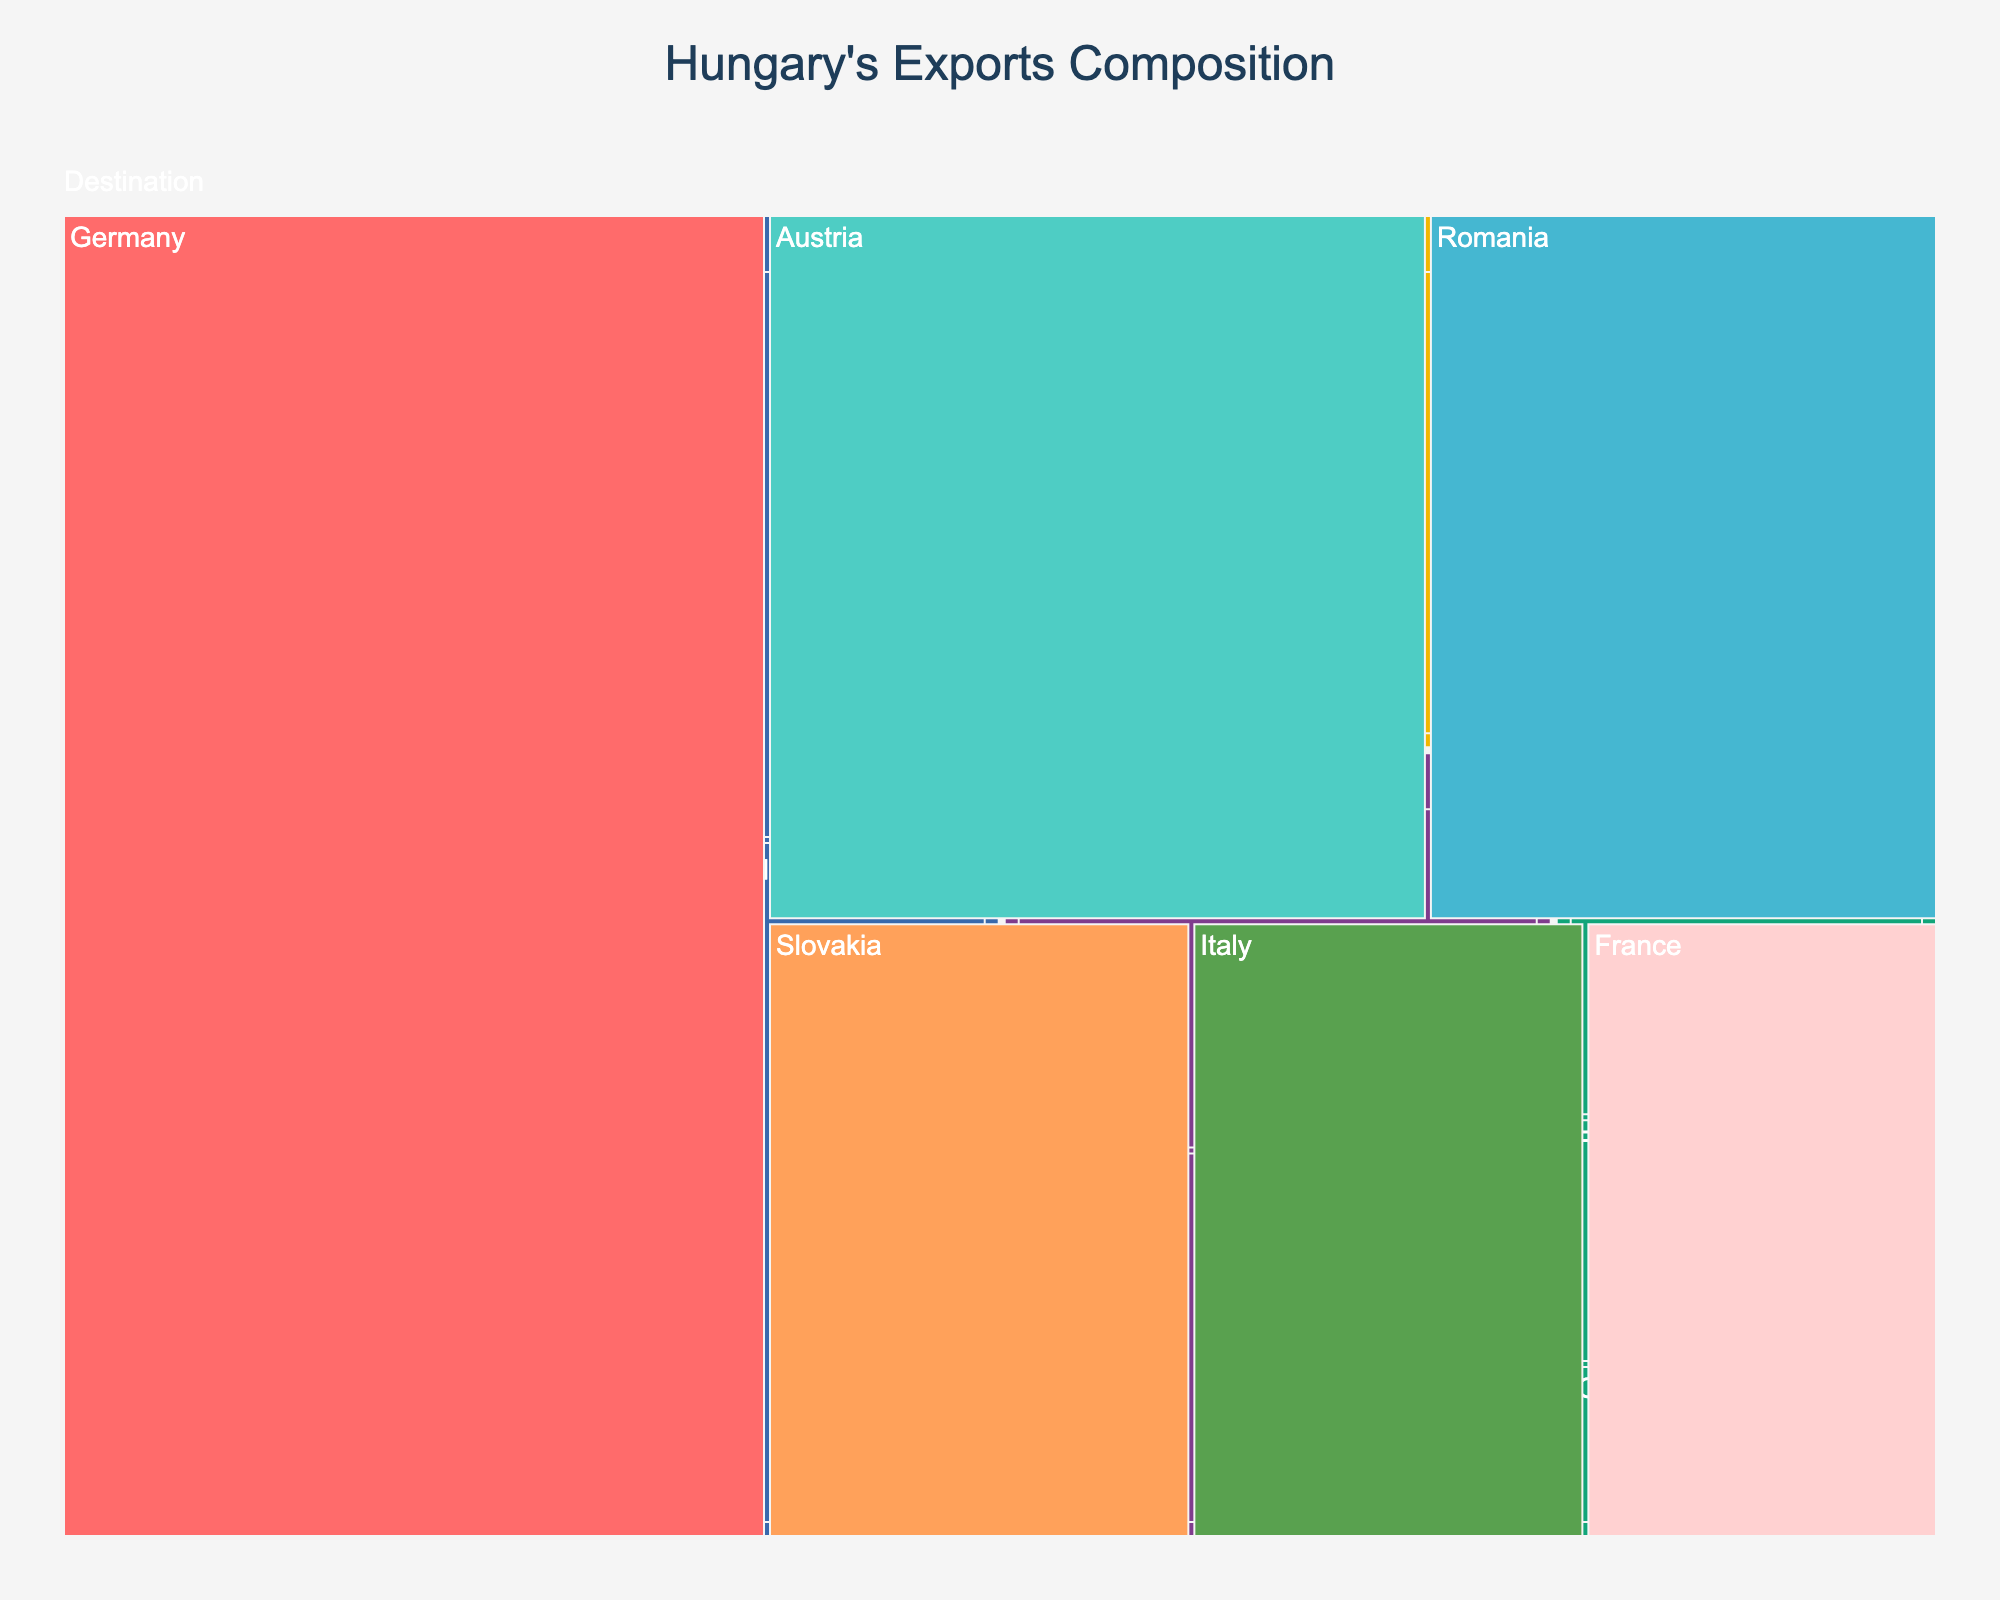What is the title of the treemap? The title of the treemap is positioned at the top center and is usually larger and more distinctively colored than other text elements.
Answer: Hungary's Exports Composition What is the largest product subcategory in the Machinery category? To determine the largest product subcategory, look at the relative sizes of the blocks within the Machinery category. The largest block by area corresponds to the Automotive subcategory.
Answer: Automotive What are the total exports for the Agricultural Products category? Sum up all the values for subcategories within Agricultural Products: Cereals (5200) + Processed Foods (3800) + Livestock (2100).
Answer: 11100 Which destination country has the highest export value? Identify the destination category and then determine the largest block within it. The largest block is labeled Germany.
Answer: Germany Compare the export values of Electronics and Pharmaceuticals subcategories. Which one is higher and by how much? Compare the specific values: Electronics (8700) and Pharmaceuticals (4600). Subtract the smaller from the larger.
Answer: Electronics is higher by 4100 What percentage of total exports does the Industrial Equipment subcategory represent? First, calculate the total exports by summing all subcategory values: 12500 + 8700 + 6300 + 5200 + 3800 + 2100 + 4600 + 3200 + 1800 + 2900 + 2300 + 1500 = 54300. Then, divide the value for Industrial Equipment (6300) by the total and multiply by 100.
Answer: Approximately 11.6% How many product categories are there in the treemap? Count the distinct top-level categories (Machinery, Agricultural Products, Chemicals, Manufactured Goods) plus the additional branch for Destination.
Answer: 5 Is the value of exports to France greater or less than the value of exports of Pharmaceuticals? Compare the provided values: Exports to France (3500) and Pharmaceuticals (4600).
Answer: Less Is there any subcategory in the Manufactured Goods category that has a higher value than the Plastics subcategory in the Chemicals category? Compare the values: Textiles (2900), Furniture (2300), Glassware (1500) vs. Plastics (3200). None of the subcategories in Manufactured Goods exceed the value for Plastics.
Answer: No What is the combined value of exports to Romania and Slovakia? Add the values for Romania (5800) and Slovakia (4200).
Answer: 10000 